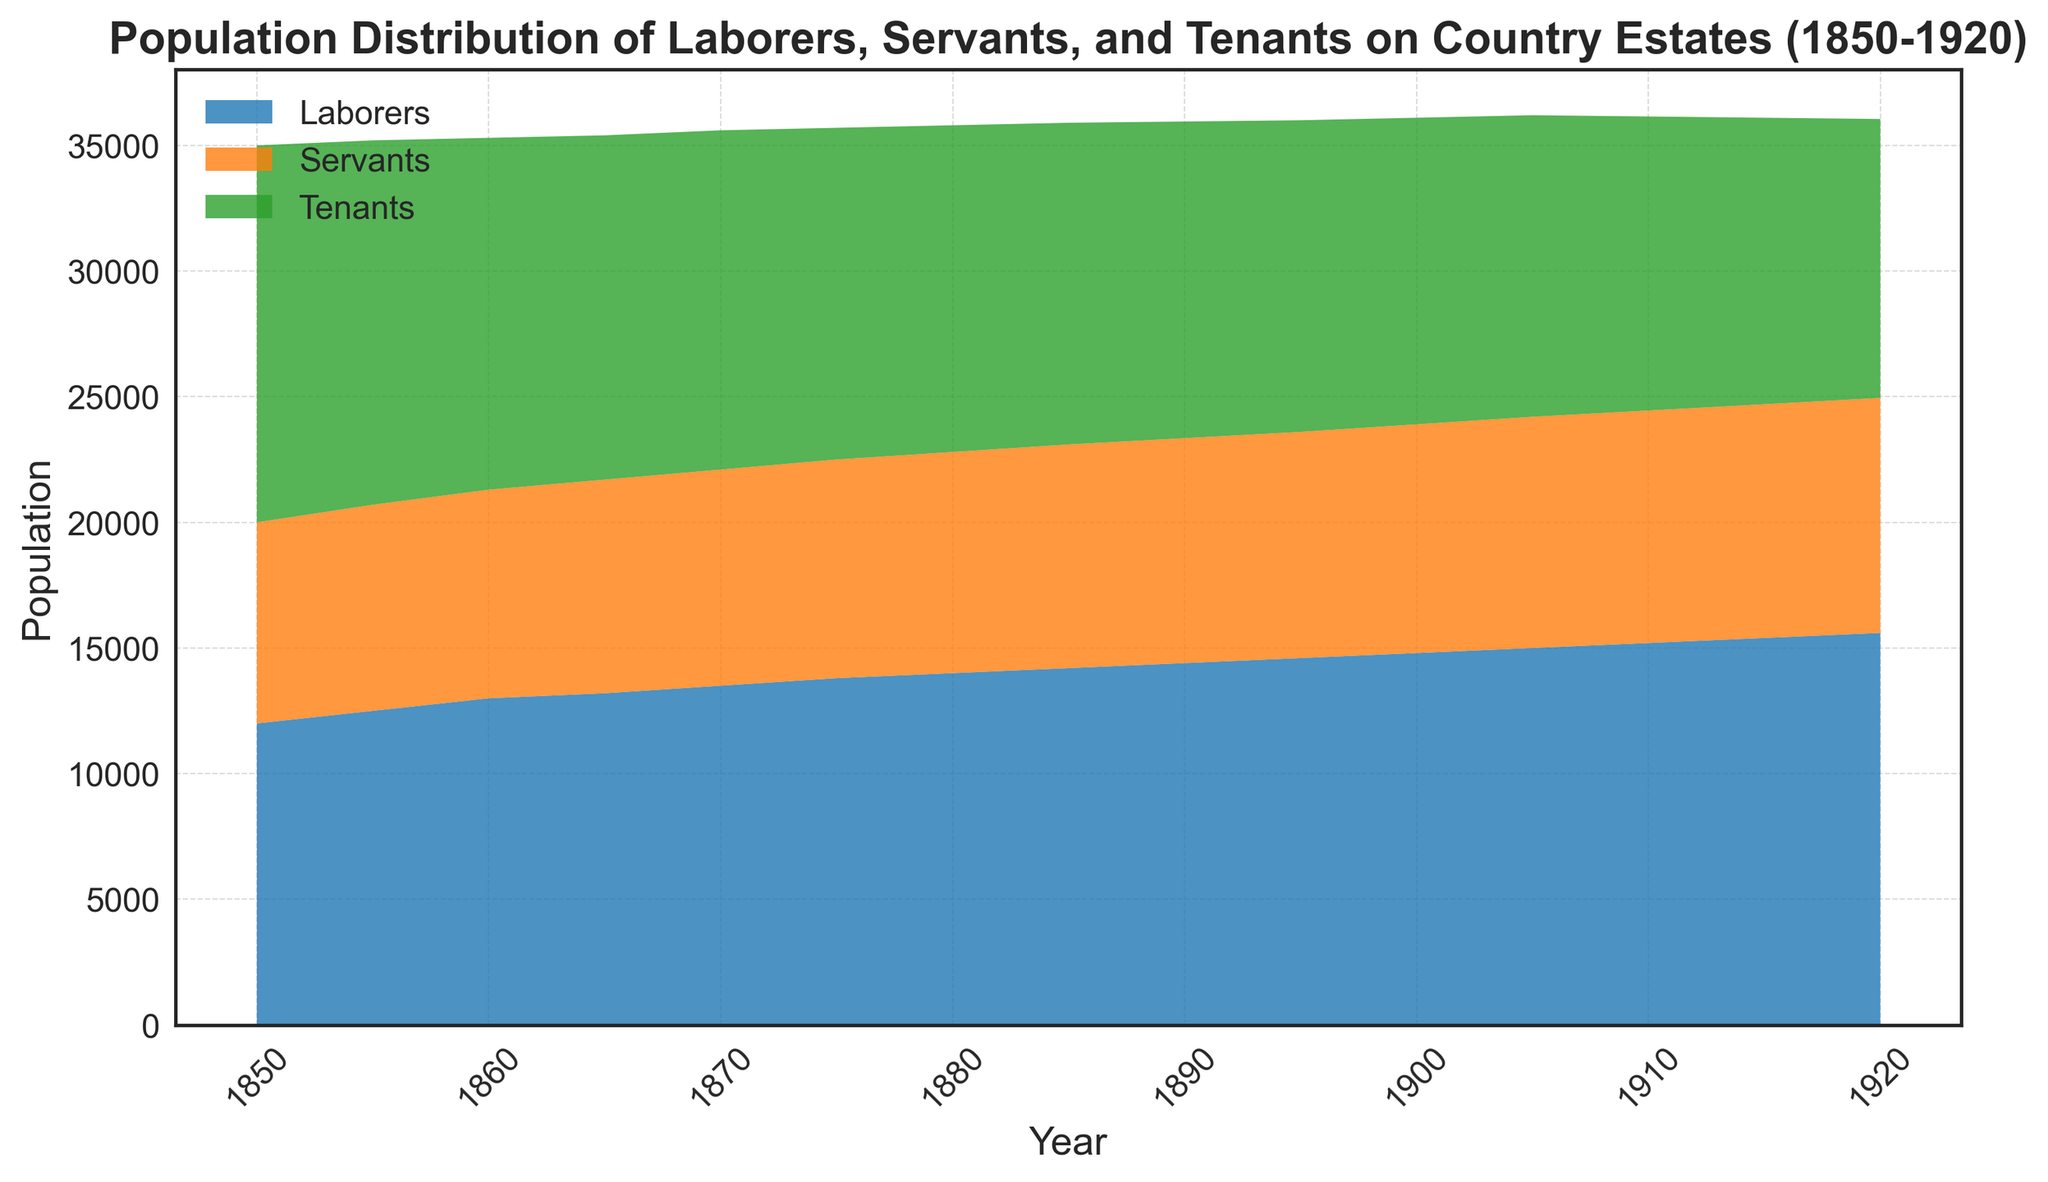What is the overall trend of the laborers' population from 1850 to 1920? The chart shows that the population of laborers increases steadily over the years from 1850 to 1920. The line representing laborers in the area chart rises continually without any significant drops.
Answer: Steadily increasing By how much did the number of tenants decrease from 1850 to 1920? To find the decrease in the number of tenants, subtract the number of tenants in 1920 from the number of tenants in 1850: 15000 - 11100 = 3900.
Answer: 3900 Around when did the number of servants surpass 9000? By looking at the timeline, the number of servants first surpasses 9000 somewhere between 1895 and 1900. Since it increased continually, the value at 1900 would definitely be over 9000.
Answer: Around 1900 In 1860, which group had the smallest population? In 1860, the smallest population can be identified by comparing the heights of the respective areas for laborers, servants, and tenants. Servants had the smallest population based on the height of the area representing them.
Answer: Servants Which group had the highest population in 1880? By comparing the heights of areas dominated by each group in 1880, we can see that tenants had the highest population.
Answer: Tenants By how much did the population of laborers and servants combined grow from 1850 to 1900? First, add the populations of laborers and servants in 1850 and in 1900. For 1850: 12000 (laborers) + 8000 (servants) = 20000. For 1900: 14800 (laborers) + 9100 (servants) = 23900. The increase from 1850 to 1900 is 23900 - 20000 = 3900.
Answer: 3900 Compare the trends of the servants' and tenants' populations over the given period. The population of servants shows a steady increase over the years from 1850 to 1920. On the other hand, the tenants' population shows a steady decline over the same period.
Answer: Servants increased, Tenants decreased What is the average population of laborers over the entire period? Sum the populations of laborers for all the given years and divide by the number of data points: (12000 + 12500 + 13000 + 13200 + 13500 + 13800 + 14000 + 14200 + 14400 + 14600 + 14800 + 15000 + 15200 + 15400 + 15600) / 15 = 13866.67.
Answer: 13866.67 Identify the year where the combined population of laborers, servants, and tenants was the closest to 35000. Calculate the combined population for each year and compare: In 1905: 15000 (laborers) + 9200 (servants) + 12000 (tenants) = 36200. 1905 is the closest to 35000 among all years.
Answer: 1905 